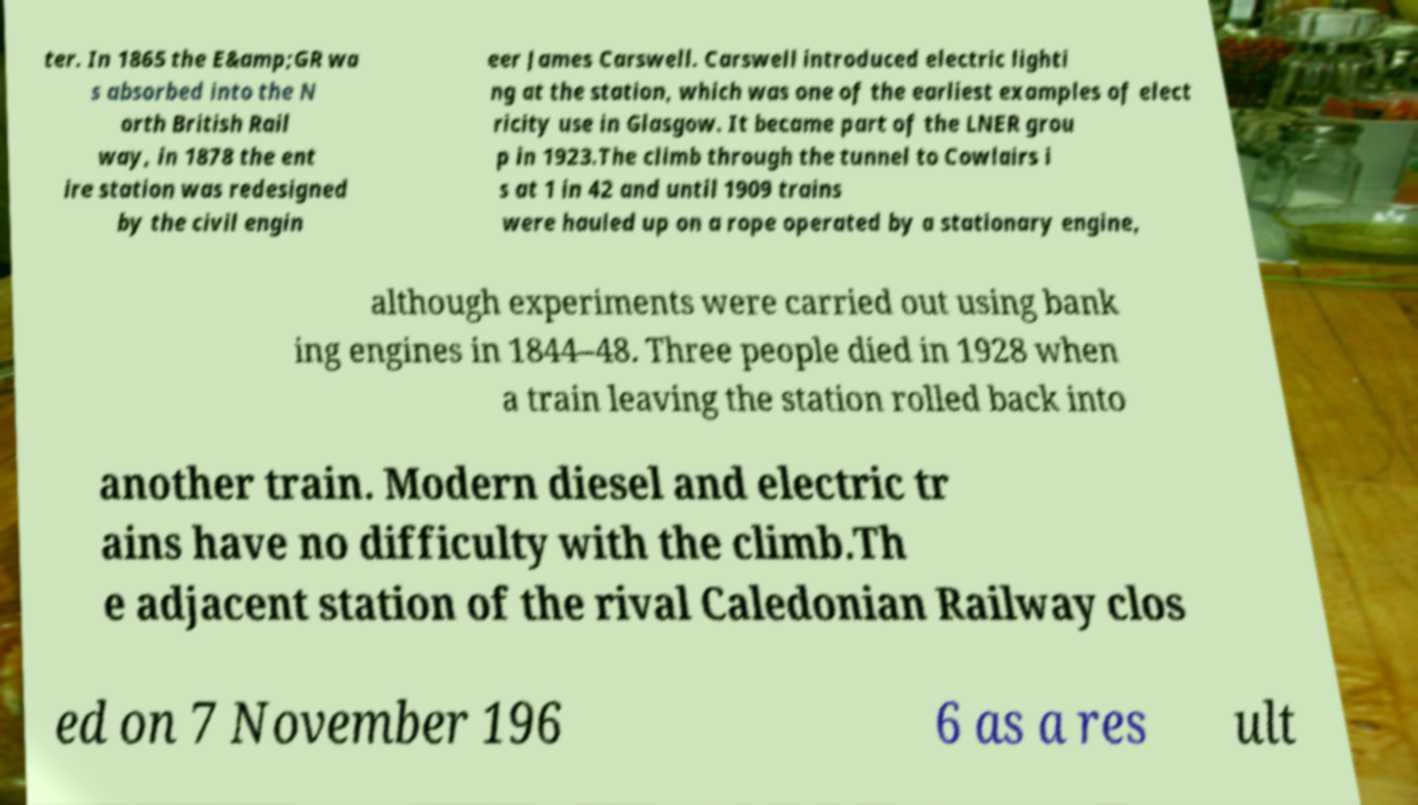Could you extract and type out the text from this image? ter. In 1865 the E&amp;GR wa s absorbed into the N orth British Rail way, in 1878 the ent ire station was redesigned by the civil engin eer James Carswell. Carswell introduced electric lighti ng at the station, which was one of the earliest examples of elect ricity use in Glasgow. It became part of the LNER grou p in 1923.The climb through the tunnel to Cowlairs i s at 1 in 42 and until 1909 trains were hauled up on a rope operated by a stationary engine, although experiments were carried out using bank ing engines in 1844–48. Three people died in 1928 when a train leaving the station rolled back into another train. Modern diesel and electric tr ains have no difficulty with the climb.Th e adjacent station of the rival Caledonian Railway clos ed on 7 November 196 6 as a res ult 